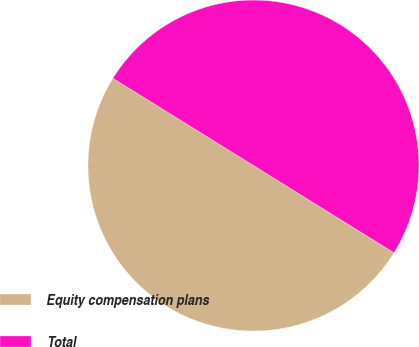Convert chart to OTSL. <chart><loc_0><loc_0><loc_500><loc_500><pie_chart><fcel>Equity compensation plans<fcel>Total<nl><fcel>50.0%<fcel>50.0%<nl></chart> 